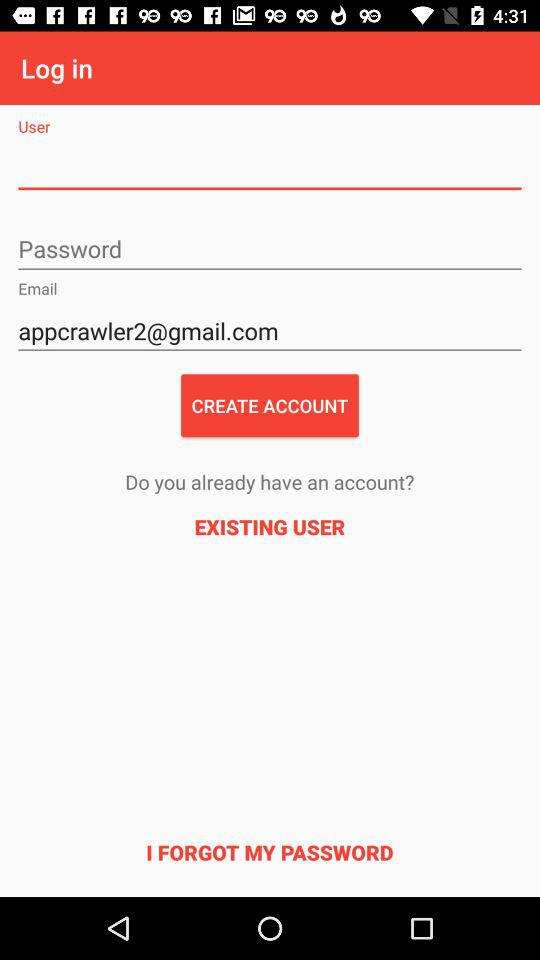What is the email address of the user? The email address of the user is appcrawler2@gmail.com. 